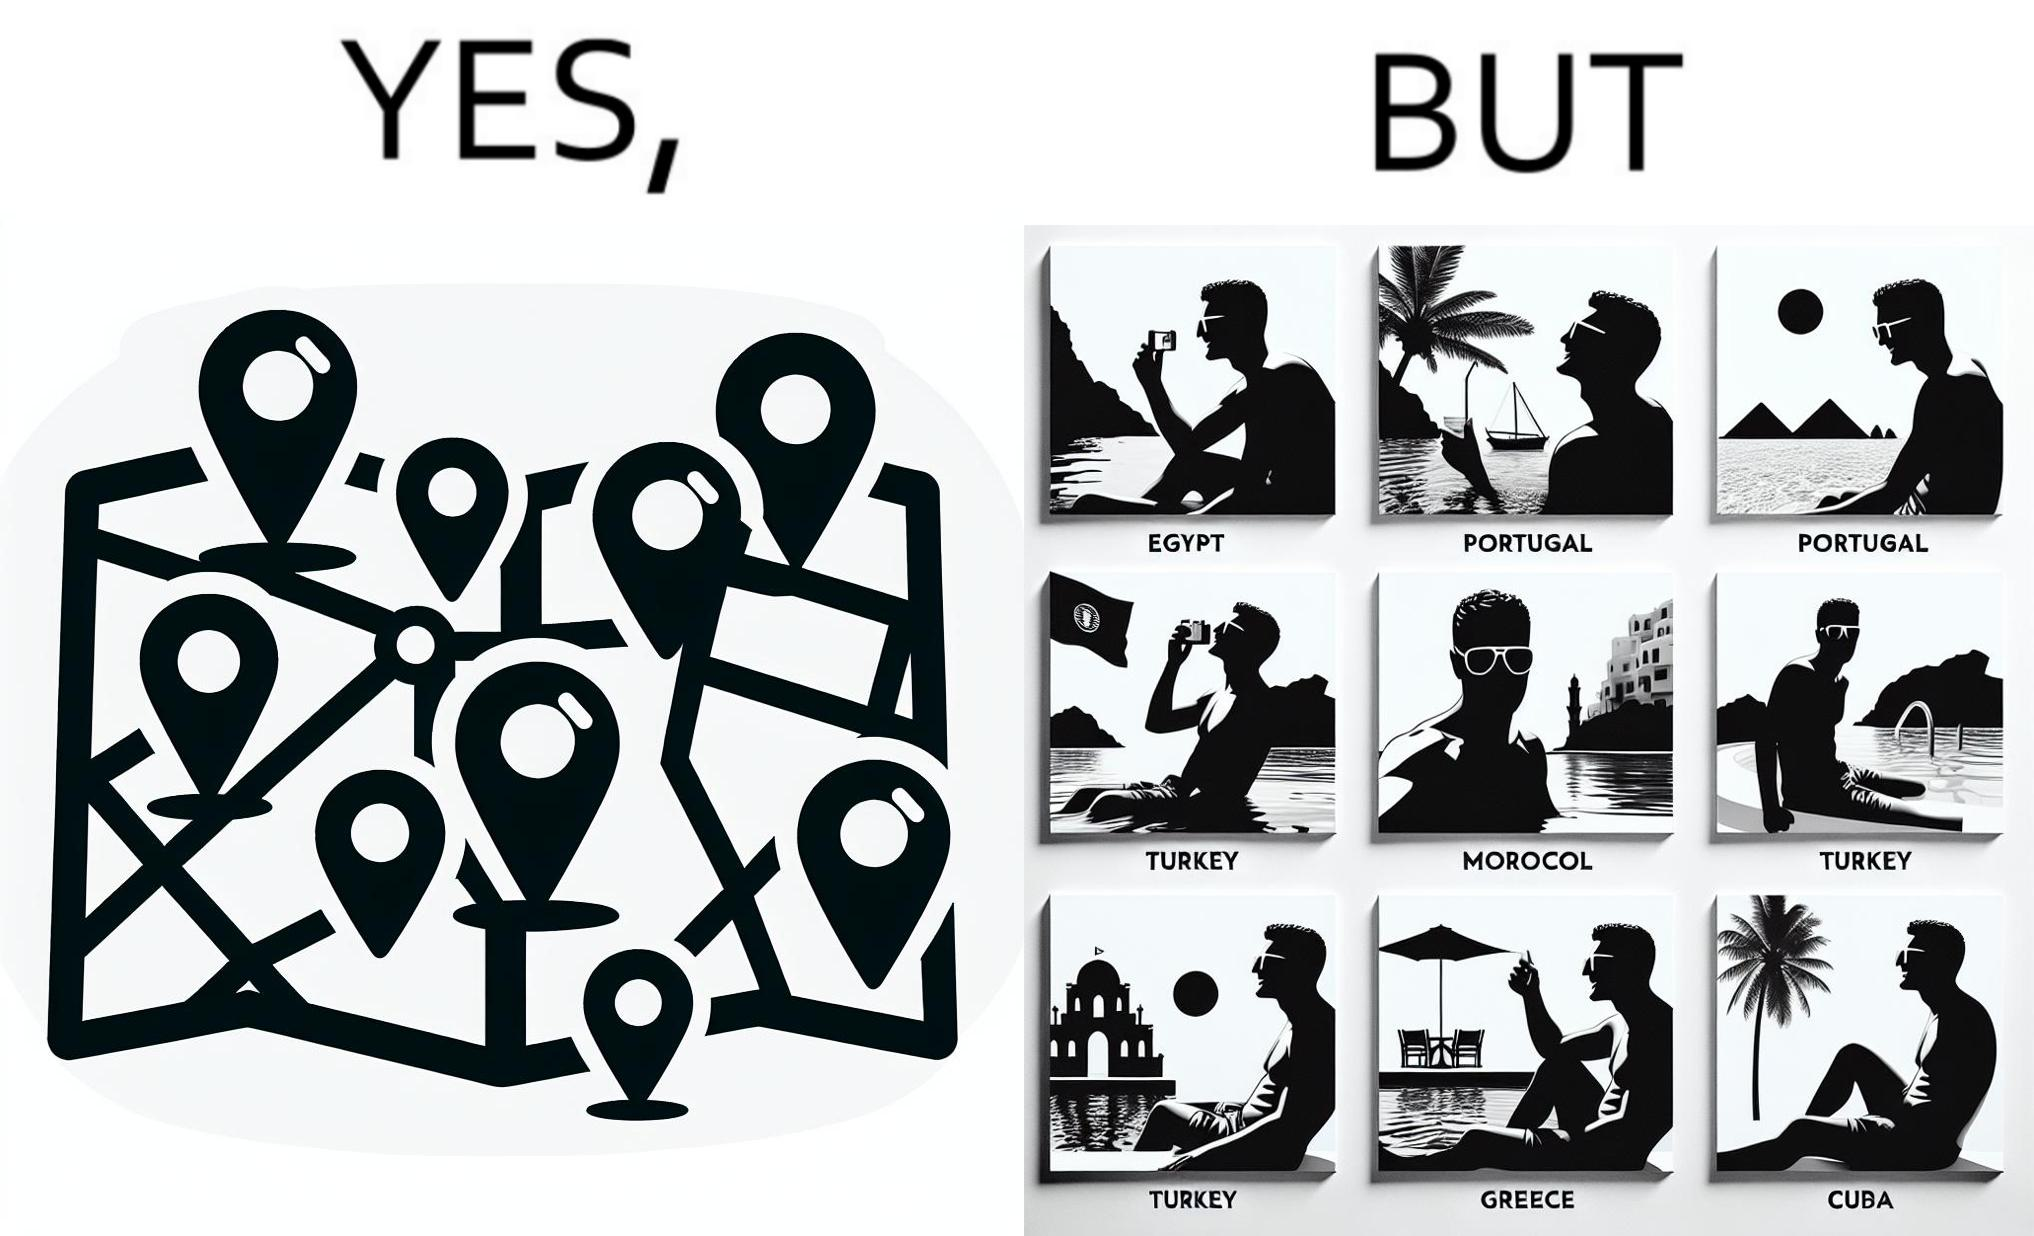Explain why this image is satirical. The image is satirical because while the man has visited all the place marked on the map, he only seems to have swam in pools in all these differnt countries and has not actually seen these places. 